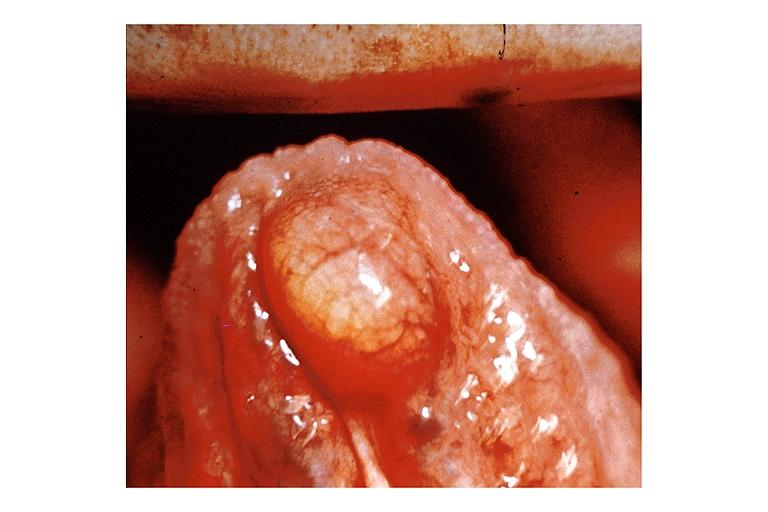does typical tuberculous exudate show lipoma?
Answer the question using a single word or phrase. No 